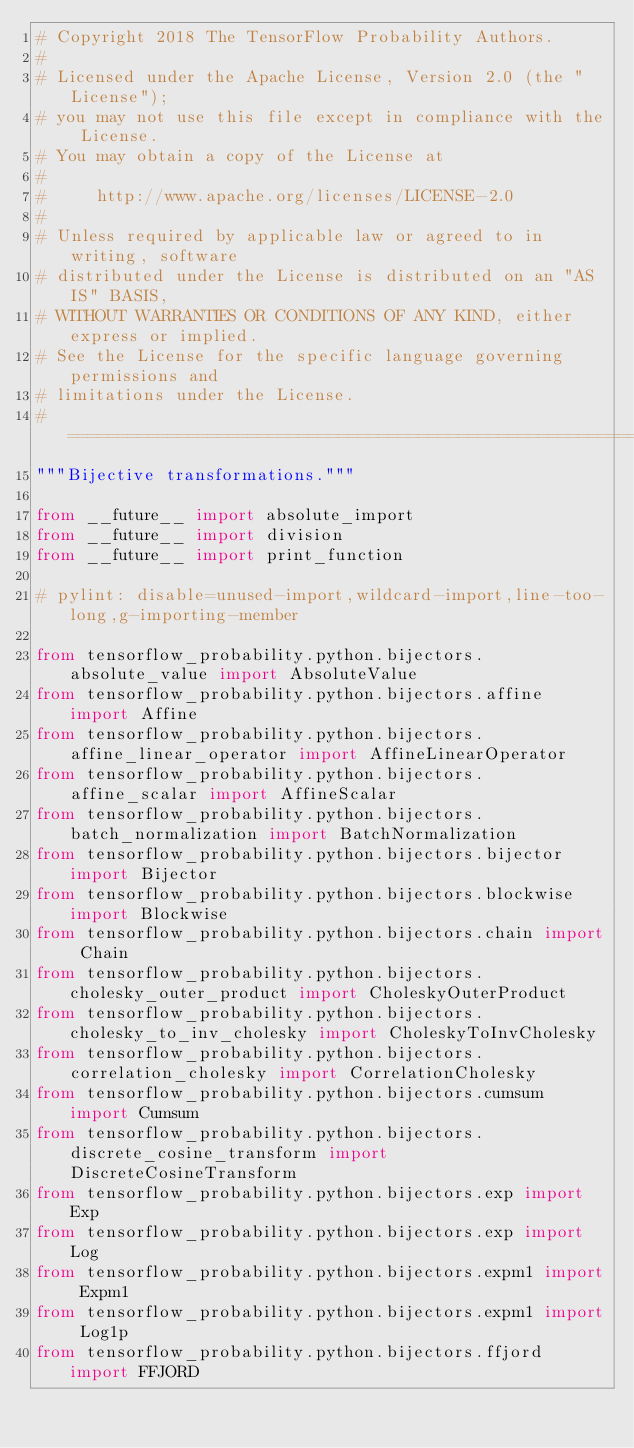<code> <loc_0><loc_0><loc_500><loc_500><_Python_># Copyright 2018 The TensorFlow Probability Authors.
#
# Licensed under the Apache License, Version 2.0 (the "License");
# you may not use this file except in compliance with the License.
# You may obtain a copy of the License at
#
#     http://www.apache.org/licenses/LICENSE-2.0
#
# Unless required by applicable law or agreed to in writing, software
# distributed under the License is distributed on an "AS IS" BASIS,
# WITHOUT WARRANTIES OR CONDITIONS OF ANY KIND, either express or implied.
# See the License for the specific language governing permissions and
# limitations under the License.
# ============================================================================
"""Bijective transformations."""

from __future__ import absolute_import
from __future__ import division
from __future__ import print_function

# pylint: disable=unused-import,wildcard-import,line-too-long,g-importing-member

from tensorflow_probability.python.bijectors.absolute_value import AbsoluteValue
from tensorflow_probability.python.bijectors.affine import Affine
from tensorflow_probability.python.bijectors.affine_linear_operator import AffineLinearOperator
from tensorflow_probability.python.bijectors.affine_scalar import AffineScalar
from tensorflow_probability.python.bijectors.batch_normalization import BatchNormalization
from tensorflow_probability.python.bijectors.bijector import Bijector
from tensorflow_probability.python.bijectors.blockwise import Blockwise
from tensorflow_probability.python.bijectors.chain import Chain
from tensorflow_probability.python.bijectors.cholesky_outer_product import CholeskyOuterProduct
from tensorflow_probability.python.bijectors.cholesky_to_inv_cholesky import CholeskyToInvCholesky
from tensorflow_probability.python.bijectors.correlation_cholesky import CorrelationCholesky
from tensorflow_probability.python.bijectors.cumsum import Cumsum
from tensorflow_probability.python.bijectors.discrete_cosine_transform import DiscreteCosineTransform
from tensorflow_probability.python.bijectors.exp import Exp
from tensorflow_probability.python.bijectors.exp import Log
from tensorflow_probability.python.bijectors.expm1 import Expm1
from tensorflow_probability.python.bijectors.expm1 import Log1p
from tensorflow_probability.python.bijectors.ffjord import FFJORD</code> 